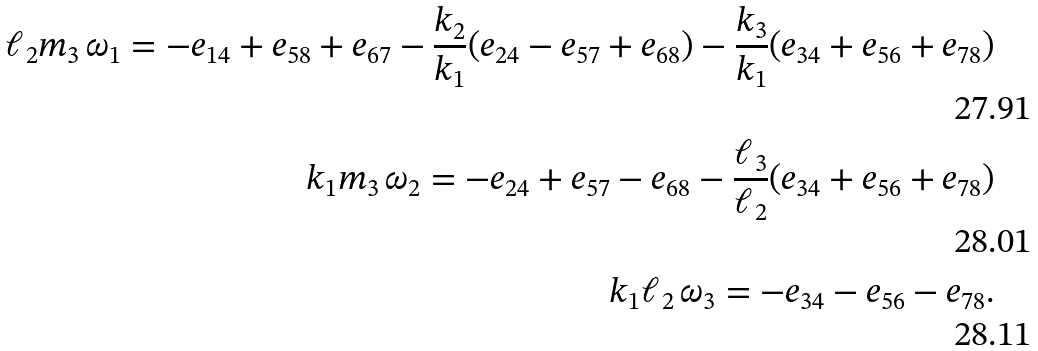Convert formula to latex. <formula><loc_0><loc_0><loc_500><loc_500>\ell _ { 2 } m _ { 3 } \, \omega _ { 1 } = - e _ { 1 4 } + e _ { 5 8 } + e _ { 6 7 } - \frac { k _ { 2 } } { k _ { 1 } } ( e _ { 2 4 } - e _ { 5 7 } + e _ { 6 8 } ) - \frac { k _ { 3 } } { k _ { 1 } } ( e _ { 3 4 } + e _ { 5 6 } + e _ { 7 8 } ) \\ k _ { 1 } m _ { 3 } \, \omega _ { 2 } = - e _ { 2 4 } + e _ { 5 7 } - e _ { 6 8 } - \frac { \ell _ { 3 } } { \ell _ { 2 } } ( e _ { 3 4 } + e _ { 5 6 } + e _ { 7 8 } ) \\ k _ { 1 } \ell _ { 2 } \, \omega _ { 3 } = - e _ { 3 4 } - e _ { 5 6 } - e _ { 7 8 } .</formula> 